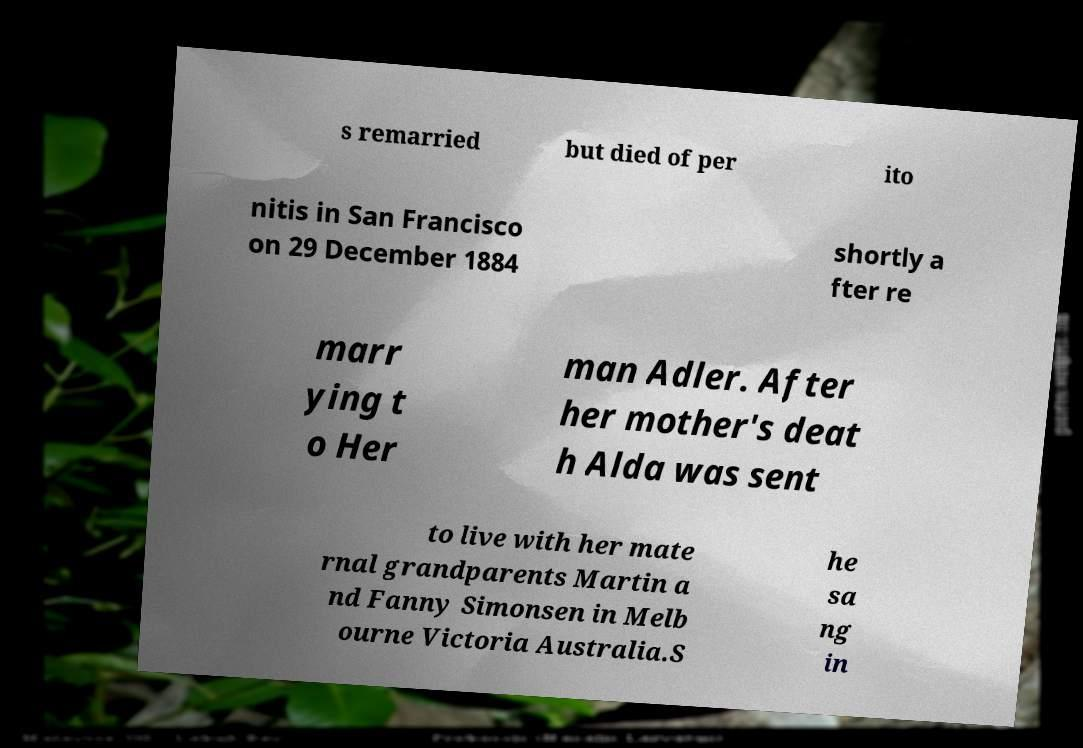Can you accurately transcribe the text from the provided image for me? s remarried but died of per ito nitis in San Francisco on 29 December 1884 shortly a fter re marr ying t o Her man Adler. After her mother's deat h Alda was sent to live with her mate rnal grandparents Martin a nd Fanny Simonsen in Melb ourne Victoria Australia.S he sa ng in 